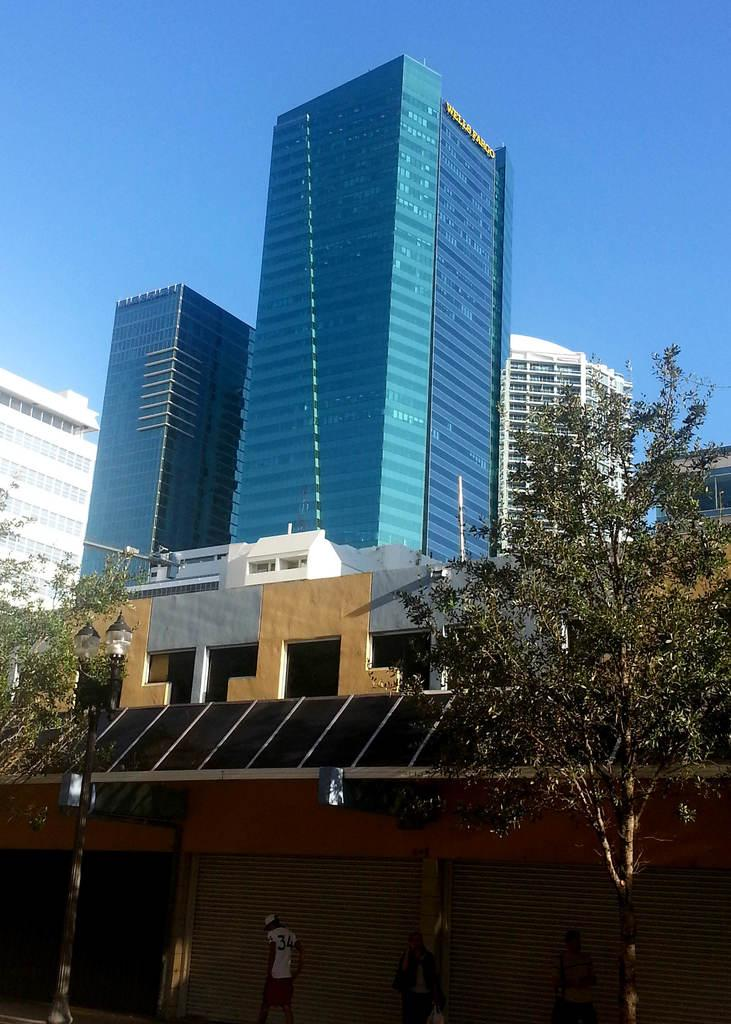What are the people in the image doing? The people in the image are walking. What type of natural elements can be seen in the image? There are trees in the image. What type of man-made structures are present in the image? There are buildings in the image. What is the color of the sky in the image? The sky is blue in the image. What level of competition are the people participating in the image? There is no indication of any competition in the image; it simply shows people walking. What type of shame is associated with the trees in the image? There is no shame associated with the trees in the image; they are simply part of the natural landscape. 